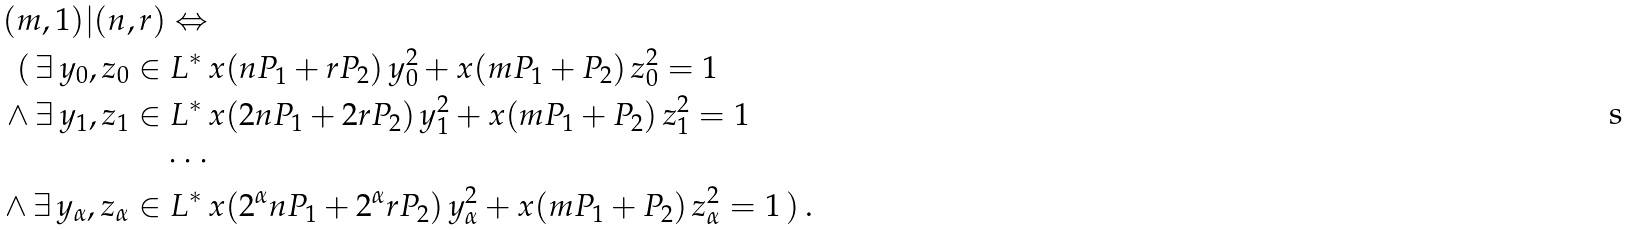Convert formula to latex. <formula><loc_0><loc_0><loc_500><loc_500>( m , 1 ) | ( n , r ) \Leftrightarrow \\ ( \, \exists \, y _ { 0 } , z _ { 0 } \in L ^ { * } \, & x ( n P _ { 1 } + r P _ { 2 } ) \, y _ { 0 } ^ { 2 } + x ( m P _ { 1 } + P _ { 2 } ) \, z _ { 0 } ^ { 2 } = 1 \\ \land \, \exists \, y _ { 1 } , z _ { 1 } \in L ^ { * } \, & x ( 2 n P _ { 1 } + 2 r P _ { 2 } ) \, y _ { 1 } ^ { 2 } + x ( m P _ { 1 } + P _ { 2 } ) \, z _ { 1 } ^ { 2 } = 1 \\ \cdots \\ \land \, \exists \, y _ { \alpha } , z _ { \alpha } \in L ^ { * } \, & x ( 2 ^ { \alpha } n P _ { 1 } + 2 ^ { \alpha } r P _ { 2 } ) \, y _ { \alpha } ^ { 2 } + x ( m P _ { 1 } + P _ { 2 } ) \, z _ { \alpha } ^ { 2 } = 1 \, ) \, .</formula> 